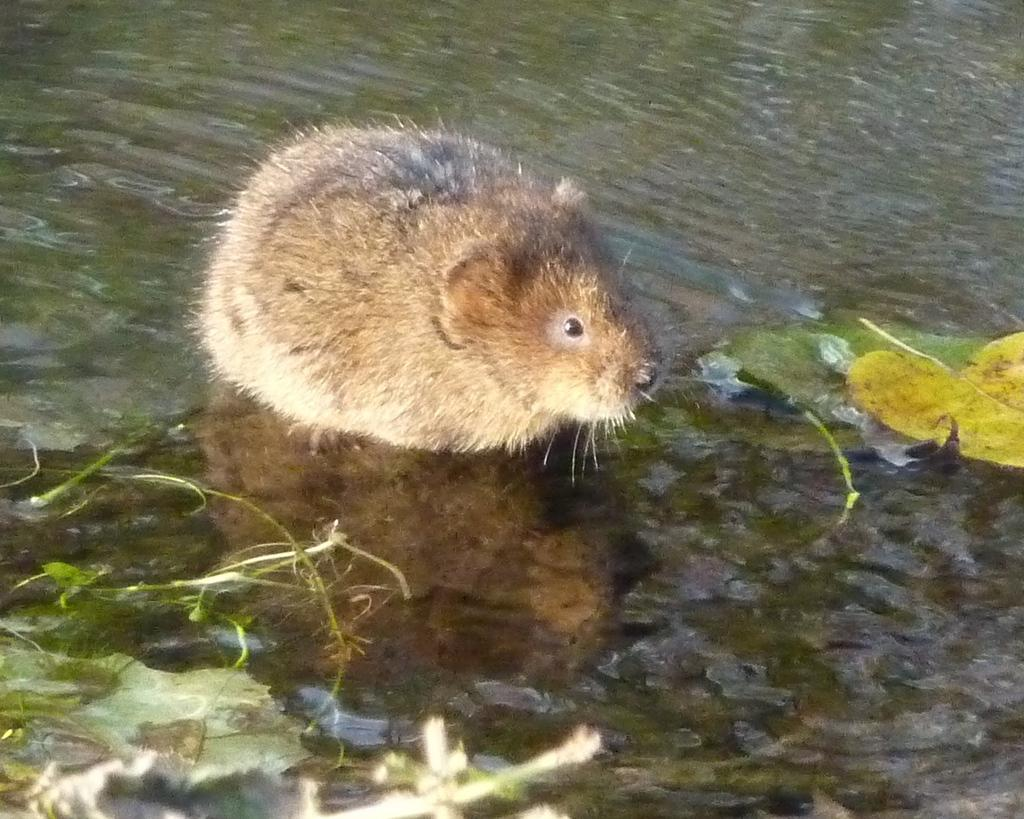What animal is present in the image? There is a rat in the image. What is the rat's position in relation to the water? The rat is standing in the water. What type of vegetation is present in front of the rat? There are leaves and stems in front of the rat. What type of floor can be seen under the rat in the image? There is no floor visible in the image, as the rat is standing in the water. How many sheep are present in the image? There are no sheep present in the image; it features a rat standing in the water with leaves and stems in front of it. 